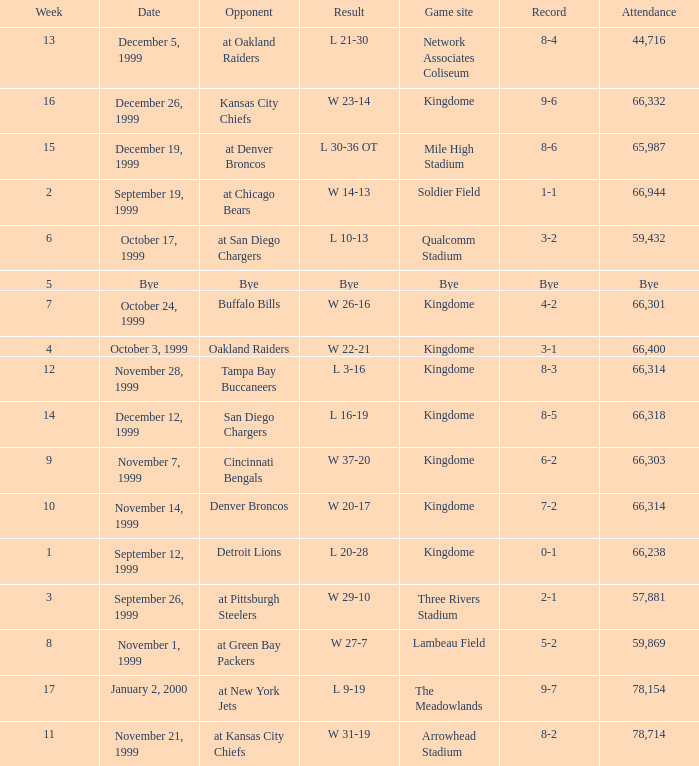What was the result of the game that was played on week 15? L 30-36 OT. I'm looking to parse the entire table for insights. Could you assist me with that? {'header': ['Week', 'Date', 'Opponent', 'Result', 'Game site', 'Record', 'Attendance'], 'rows': [['13', 'December 5, 1999', 'at Oakland Raiders', 'L 21-30', 'Network Associates Coliseum', '8-4', '44,716'], ['16', 'December 26, 1999', 'Kansas City Chiefs', 'W 23-14', 'Kingdome', '9-6', '66,332'], ['15', 'December 19, 1999', 'at Denver Broncos', 'L 30-36 OT', 'Mile High Stadium', '8-6', '65,987'], ['2', 'September 19, 1999', 'at Chicago Bears', 'W 14-13', 'Soldier Field', '1-1', '66,944'], ['6', 'October 17, 1999', 'at San Diego Chargers', 'L 10-13', 'Qualcomm Stadium', '3-2', '59,432'], ['5', 'Bye', 'Bye', 'Bye', 'Bye', 'Bye', 'Bye'], ['7', 'October 24, 1999', 'Buffalo Bills', 'W 26-16', 'Kingdome', '4-2', '66,301'], ['4', 'October 3, 1999', 'Oakland Raiders', 'W 22-21', 'Kingdome', '3-1', '66,400'], ['12', 'November 28, 1999', 'Tampa Bay Buccaneers', 'L 3-16', 'Kingdome', '8-3', '66,314'], ['14', 'December 12, 1999', 'San Diego Chargers', 'L 16-19', 'Kingdome', '8-5', '66,318'], ['9', 'November 7, 1999', 'Cincinnati Bengals', 'W 37-20', 'Kingdome', '6-2', '66,303'], ['10', 'November 14, 1999', 'Denver Broncos', 'W 20-17', 'Kingdome', '7-2', '66,314'], ['1', 'September 12, 1999', 'Detroit Lions', 'L 20-28', 'Kingdome', '0-1', '66,238'], ['3', 'September 26, 1999', 'at Pittsburgh Steelers', 'W 29-10', 'Three Rivers Stadium', '2-1', '57,881'], ['8', 'November 1, 1999', 'at Green Bay Packers', 'W 27-7', 'Lambeau Field', '5-2', '59,869'], ['17', 'January 2, 2000', 'at New York Jets', 'L 9-19', 'The Meadowlands', '9-7', '78,154'], ['11', 'November 21, 1999', 'at Kansas City Chiefs', 'W 31-19', 'Arrowhead Stadium', '8-2', '78,714']]} 